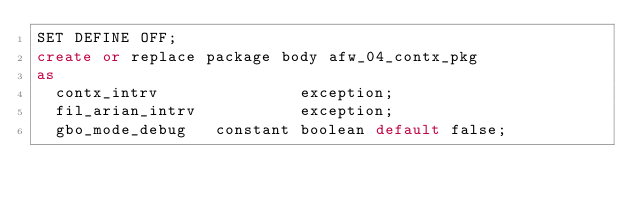<code> <loc_0><loc_0><loc_500><loc_500><_SQL_>SET DEFINE OFF;
create or replace package body afw_04_contx_pkg
as
  contx_intrv               exception;
  fil_arian_intrv           exception;
  gbo_mode_debug   constant boolean default false;
</code> 